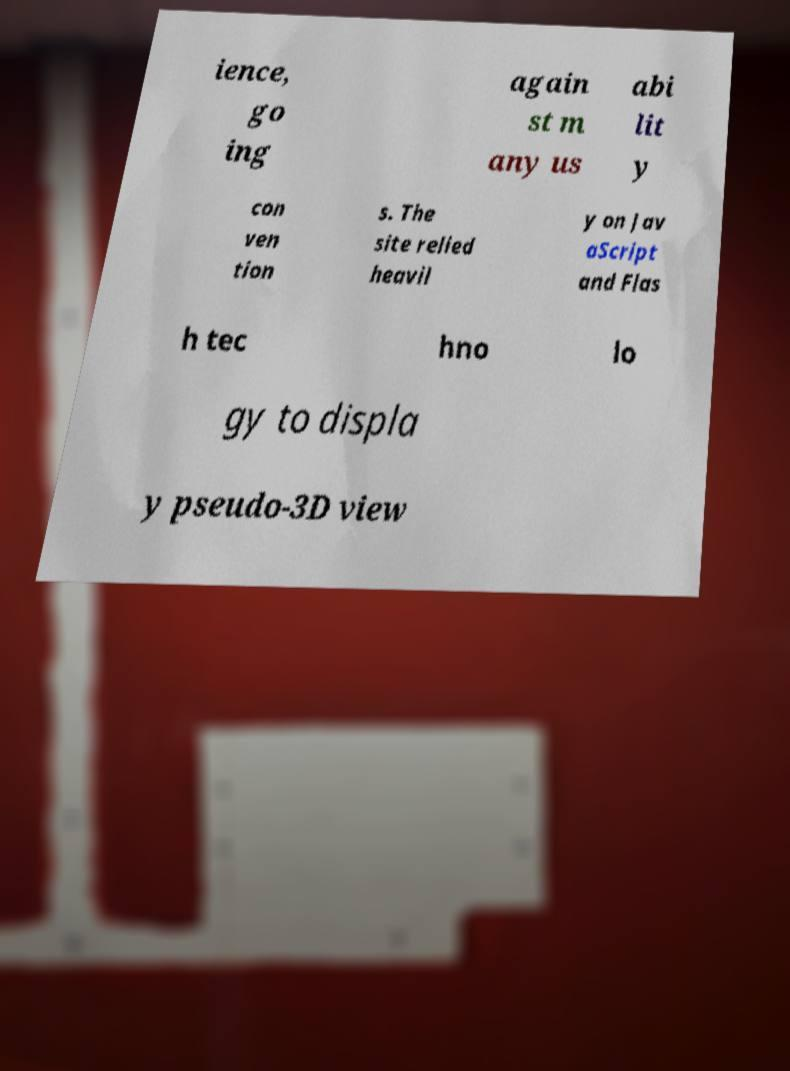Please identify and transcribe the text found in this image. ience, go ing again st m any us abi lit y con ven tion s. The site relied heavil y on Jav aScript and Flas h tec hno lo gy to displa y pseudo-3D view 